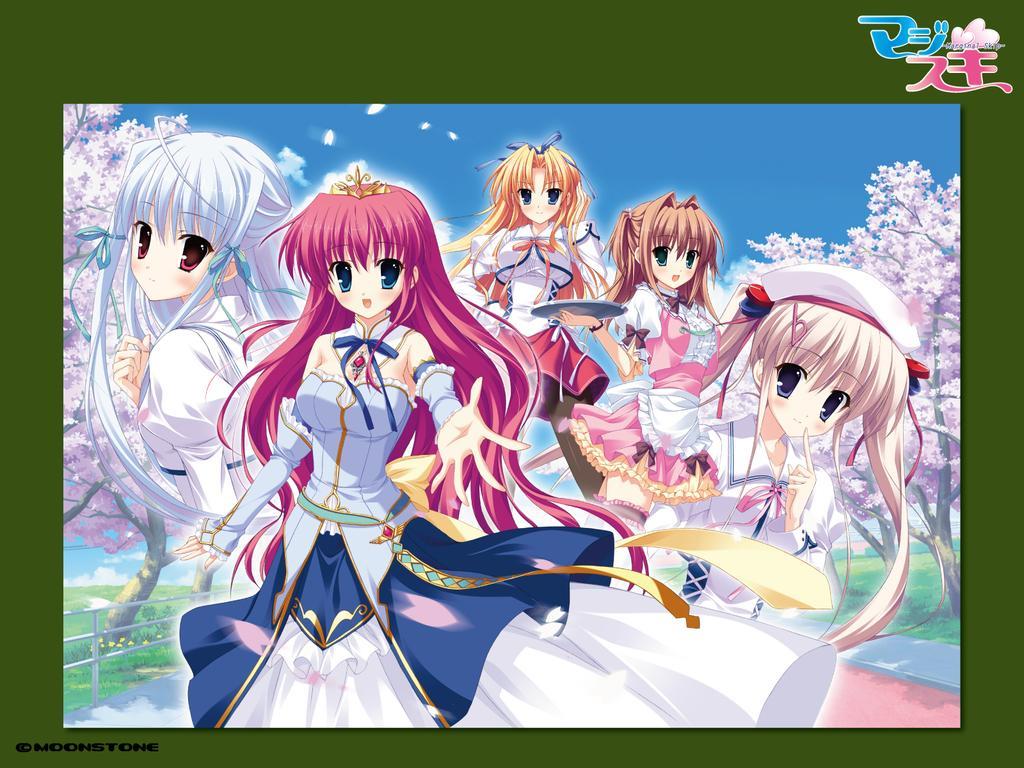Could you give a brief overview of what you see in this image? In this picture I can see cartoon character of girls. Here I can see five girls in different type of dresses. In the background I can see pink color of trees and a blue sky. I can see one girl is holding a plate in her hand. 